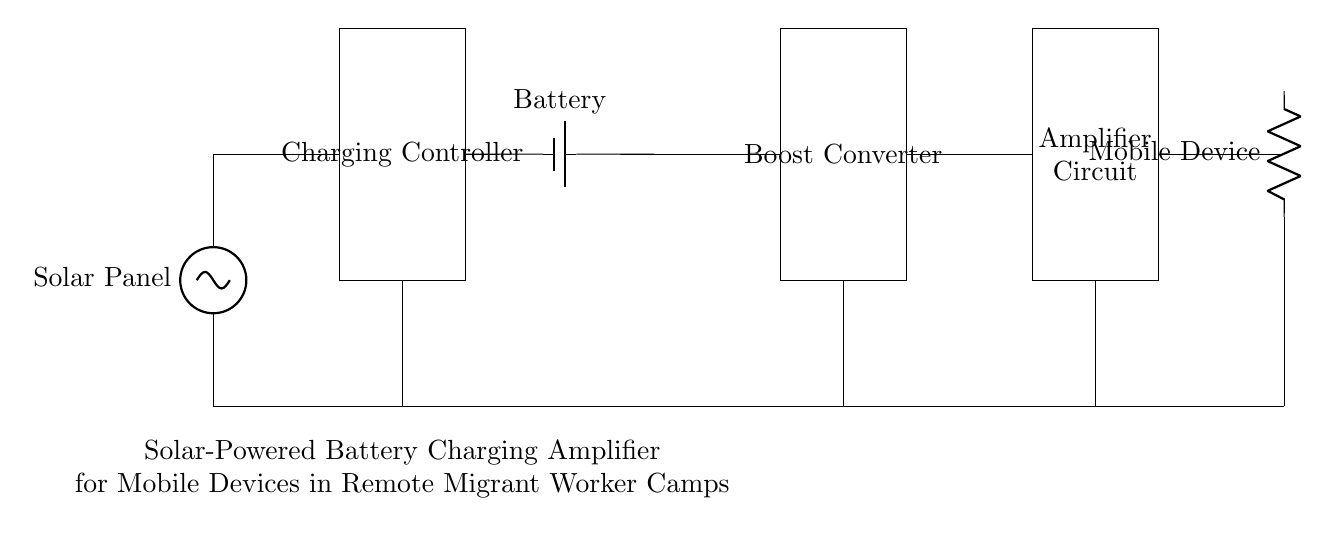What is the main component providing power in this circuit? The main component providing power is the solar panel, which converts sunlight into electrical energy.
Answer: Solar Panel What does the battery do in this circuit? The battery stores the energy generated by the solar panel and provides a stable voltage output when the system is running.
Answer: Stores energy What is the role of the boost converter? The boost converter steps up the voltage from the battery to ensure it meets the required voltage level for the amplifier circuit.
Answer: Voltage step-up How many main components are used in this charging circuit? There are five main components: Solar Panel, Charging Controller, Battery, Boost Converter, and Amplifier.
Answer: Five What type of load is connected at the output of the amplifier? The load connected at the output of the amplifier is a mobile device that requires charging.
Answer: Mobile Device What is the purpose of the amplifier circuit in the context of this setup? The amplifier circuit increases the voltage and current levels suitable for charging mobile devices efficiently.
Answer: Voltage and current increase How does the charging controller contribute to the system? The charging controller manages the flow of electricity from the solar panel to the battery, preventing overcharging and ensuring safe operation.
Answer: Manages charging 